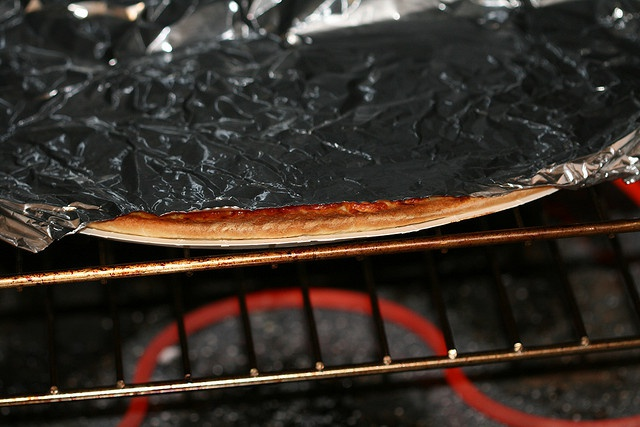Describe the objects in this image and their specific colors. I can see a pizza in black, tan, brown, and maroon tones in this image. 